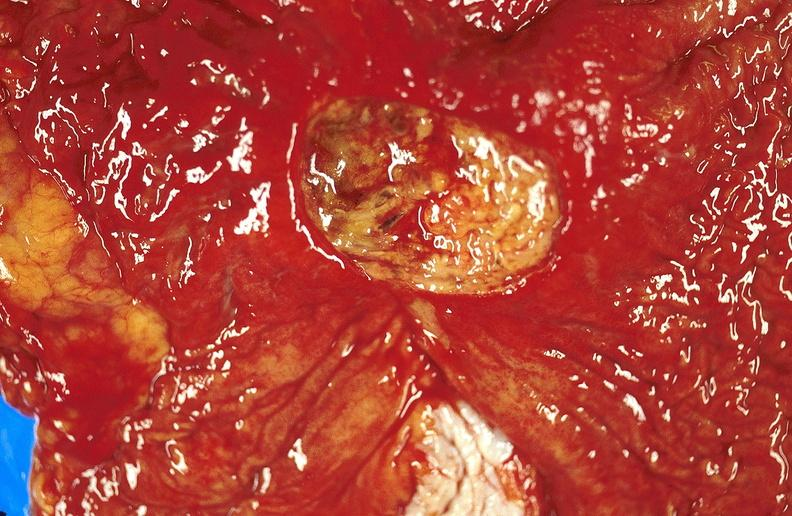what does this image show?
Answer the question using a single word or phrase. Gastric ulcer 